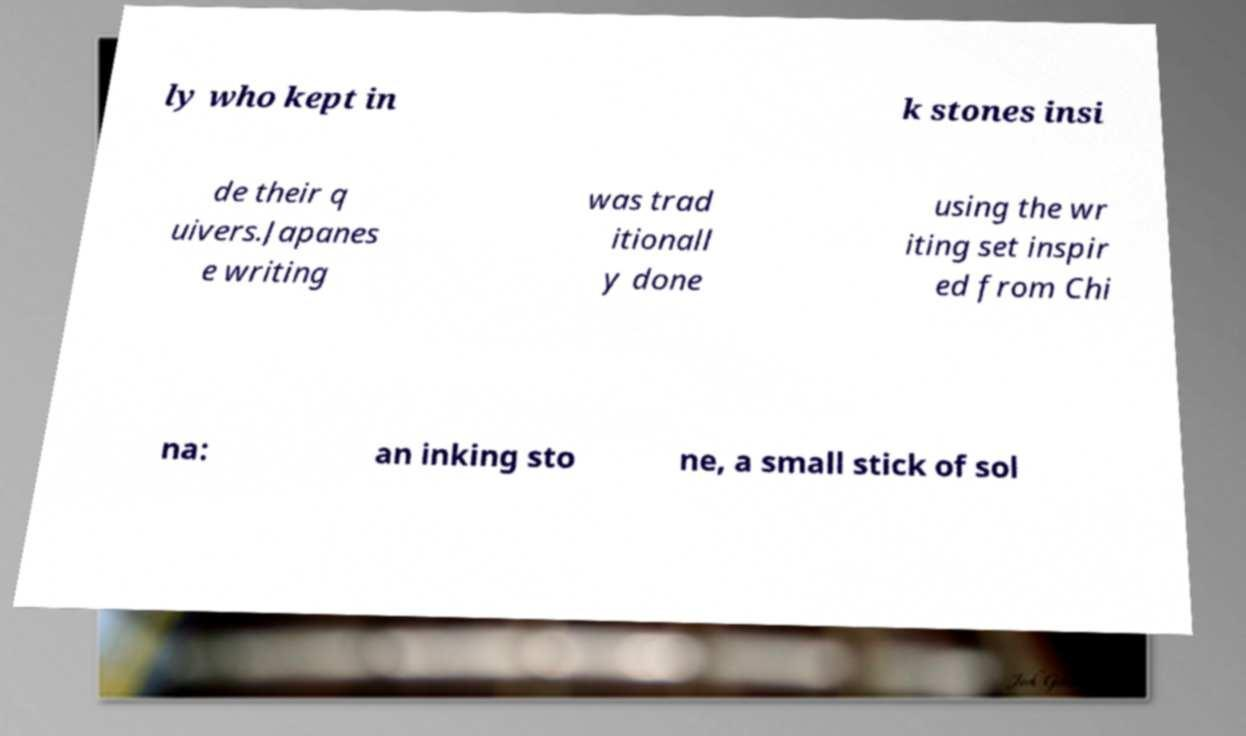Could you assist in decoding the text presented in this image and type it out clearly? ly who kept in k stones insi de their q uivers.Japanes e writing was trad itionall y done using the wr iting set inspir ed from Chi na: an inking sto ne, a small stick of sol 